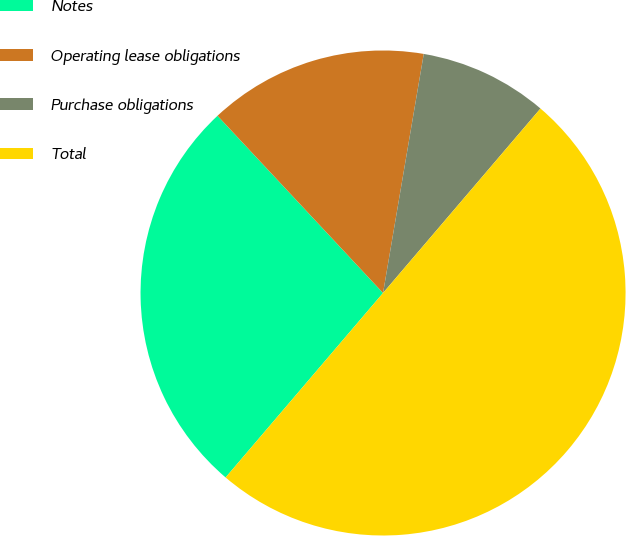Convert chart to OTSL. <chart><loc_0><loc_0><loc_500><loc_500><pie_chart><fcel>Notes<fcel>Operating lease obligations<fcel>Purchase obligations<fcel>Total<nl><fcel>26.8%<fcel>14.64%<fcel>8.56%<fcel>50.0%<nl></chart> 